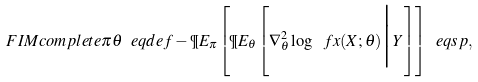Convert formula to latex. <formula><loc_0><loc_0><loc_500><loc_500>\ F I M c o m p l e t e { \pi } { \theta } \ e q d e f - \P E _ { \pi } \left [ \P E _ { \theta } \left [ \nabla _ { \theta } ^ { 2 } \log \ f x ( X ; \theta ) \Big | Y \right ] \right ] \ e q s p ,</formula> 